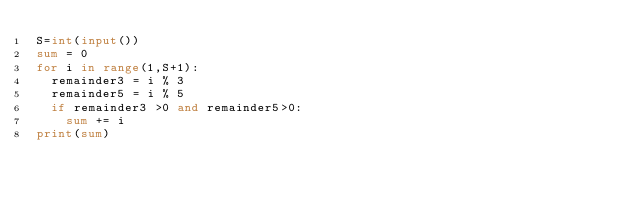Convert code to text. <code><loc_0><loc_0><loc_500><loc_500><_Python_>S=int(input())
sum = 0
for i in range(1,S+1):
  remainder3 = i % 3
  remainder5 = i % 5
  if remainder3 >0 and remainder5>0:
  	sum += i
print(sum)</code> 